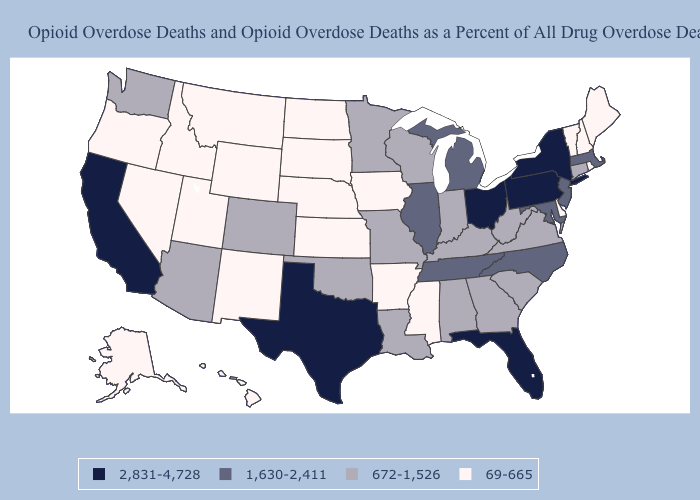Does Michigan have a higher value than Wisconsin?
Give a very brief answer. Yes. Which states have the highest value in the USA?
Keep it brief. California, Florida, New York, Ohio, Pennsylvania, Texas. Name the states that have a value in the range 672-1,526?
Write a very short answer. Alabama, Arizona, Colorado, Connecticut, Georgia, Indiana, Kentucky, Louisiana, Minnesota, Missouri, Oklahoma, South Carolina, Virginia, Washington, West Virginia, Wisconsin. Which states have the highest value in the USA?
Answer briefly. California, Florida, New York, Ohio, Pennsylvania, Texas. Does West Virginia have a higher value than Oregon?
Short answer required. Yes. Does California have the highest value in the West?
Short answer required. Yes. Does Connecticut have a higher value than Arkansas?
Give a very brief answer. Yes. Name the states that have a value in the range 1,630-2,411?
Give a very brief answer. Illinois, Maryland, Massachusetts, Michigan, New Jersey, North Carolina, Tennessee. What is the value of Virginia?
Keep it brief. 672-1,526. How many symbols are there in the legend?
Short answer required. 4. How many symbols are there in the legend?
Answer briefly. 4. What is the value of Rhode Island?
Answer briefly. 69-665. What is the highest value in the USA?
Short answer required. 2,831-4,728. What is the value of Utah?
Keep it brief. 69-665. Does Maine have the lowest value in the USA?
Quick response, please. Yes. 